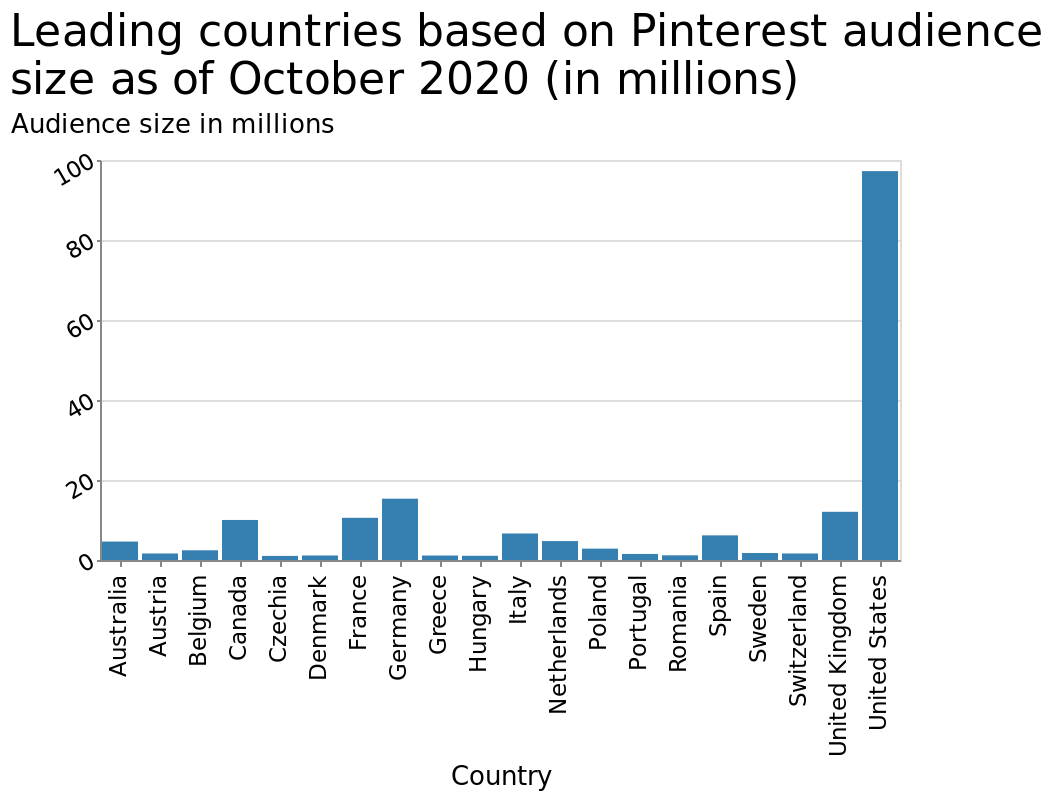<image>
What information does the bar diagram provide about the countries? The bar diagram provides information about the audience size of leading countries on Pinterest, measured in millions. How does Pinterest usage in the US compare to other countries? In comparison to every other country, Pinterest usage in the US is significantly higher. 